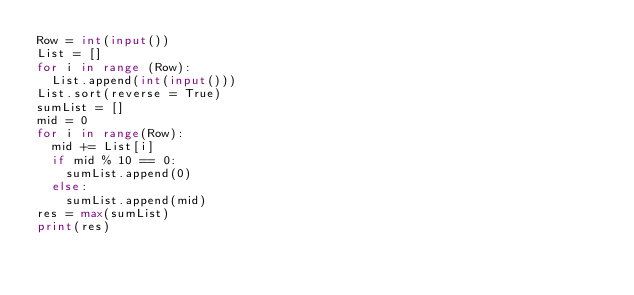Convert code to text. <code><loc_0><loc_0><loc_500><loc_500><_Python_>Row = int(input())
List = []
for i in range (Row):
  List.append(int(input()))
List.sort(reverse = True)
sumList = []
mid = 0
for i in range(Row):
  mid += List[i]
  if mid % 10 == 0:
    sumList.append(0)
  else:
    sumList.append(mid)
res = max(sumList)
print(res)</code> 